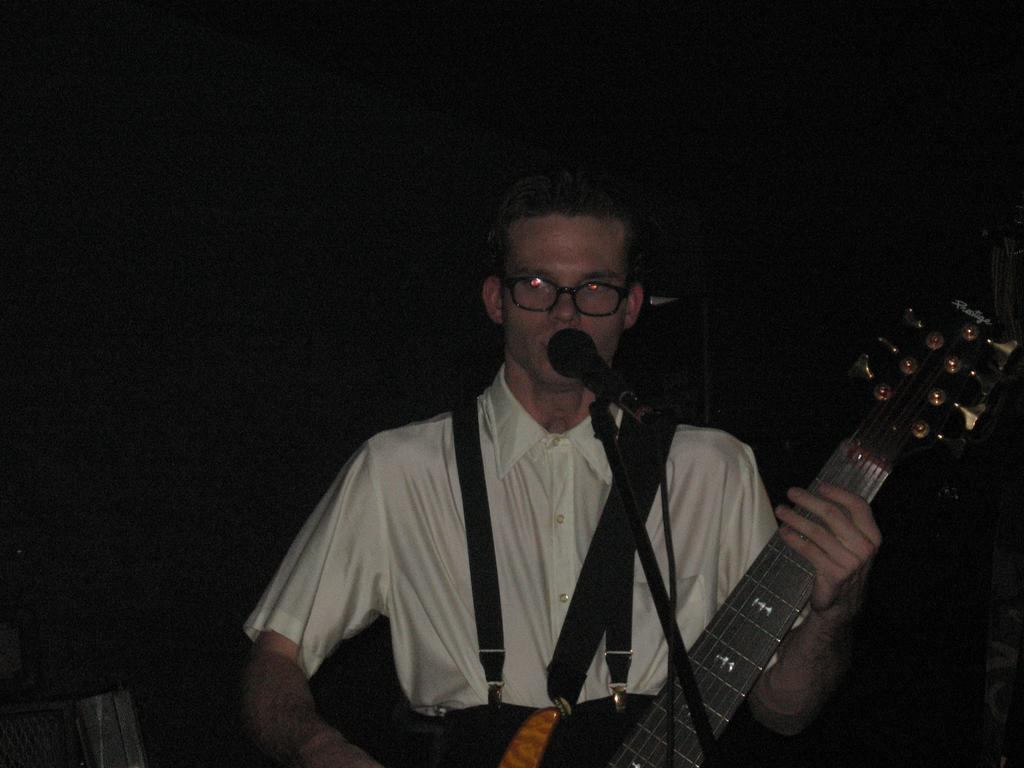Who is the main subject in the image? There is a person in the image. What is the person doing in the image? The person is standing in front of a microphone and holding a guitar. What can be seen in the background of the image? The background of the image is dark in color. When was the image taken? The image was taken during night time. What type of board is being used to play a game in the image? There is no board or game present in the image; it features a person standing in front of a microphone and holding a guitar. How many coughs can be heard in the image? There are no coughs present in the image; it is a still photograph. 